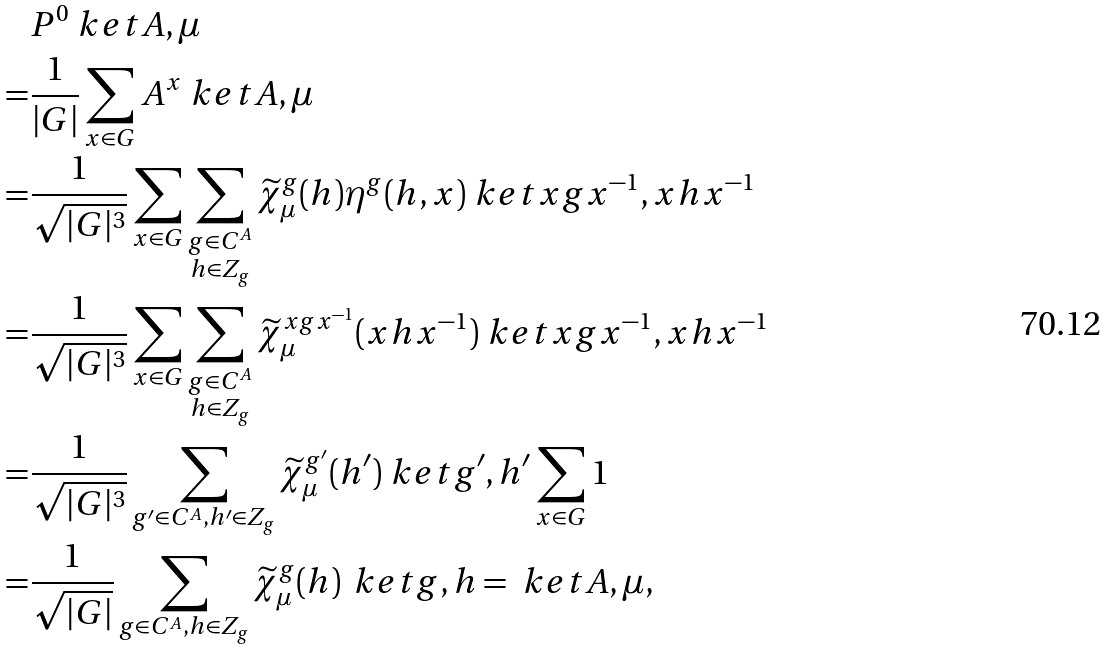<formula> <loc_0><loc_0><loc_500><loc_500>& P ^ { 0 } \ k e t { A , \mu } \\ = & \frac { 1 } { | G | } \sum _ { x \in G } A ^ { x } \ k e t { A , \mu } \\ = & \frac { 1 } { \sqrt { | G | ^ { 3 } } } \sum _ { x \in G } \sum _ { \substack { g \in C ^ { A } \\ h \in Z _ { g } } } \widetilde { \chi } ^ { g } _ { \mu } ( h ) \eta ^ { g } ( h , x ) \ k e t { x g x ^ { - 1 } , x h x ^ { - 1 } } \\ = & \frac { 1 } { \sqrt { | G | ^ { 3 } } } \sum _ { x \in G } \sum _ { \substack { g \in C ^ { A } \\ h \in Z _ { g } } } \widetilde { \chi } ^ { x g x ^ { - 1 } } _ { \mu } ( x h x ^ { - 1 } ) \ k e t { x g x ^ { - 1 } , x h x ^ { - 1 } } \\ = & \frac { 1 } { \sqrt { | G | ^ { 3 } } } \sum _ { g ^ { \prime } \in C ^ { A } , h ^ { \prime } \in Z _ { g } } \widetilde { \chi } ^ { g ^ { \prime } } _ { \mu } ( h ^ { \prime } ) \ k e t { g ^ { \prime } , h ^ { \prime } } \sum _ { x \in G } 1 \\ = & \frac { 1 } { \sqrt { | G | } } \sum _ { g \in C ^ { A } , h \in Z _ { g } } \widetilde { \chi } ^ { g } _ { \mu } ( h ) \, \ k e t { g , h } = \ k e t { A , \mu } ,</formula> 